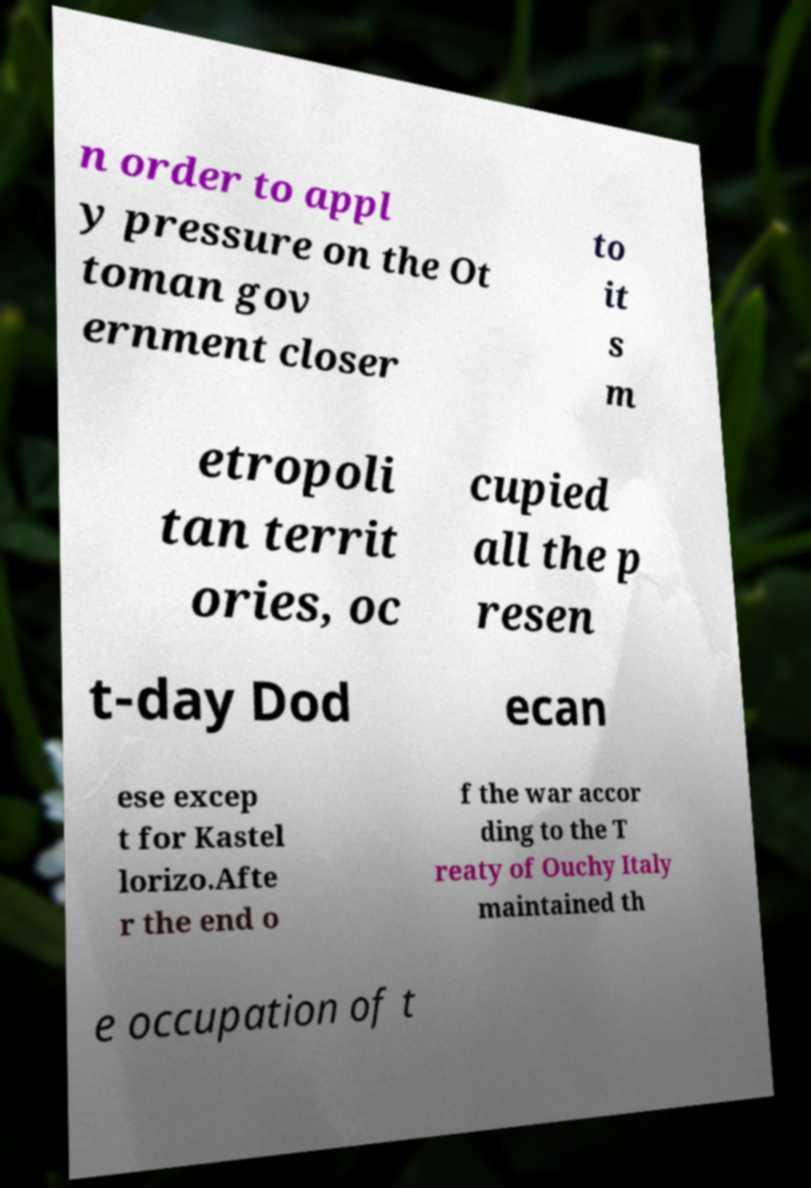There's text embedded in this image that I need extracted. Can you transcribe it verbatim? n order to appl y pressure on the Ot toman gov ernment closer to it s m etropoli tan territ ories, oc cupied all the p resen t-day Dod ecan ese excep t for Kastel lorizo.Afte r the end o f the war accor ding to the T reaty of Ouchy Italy maintained th e occupation of t 